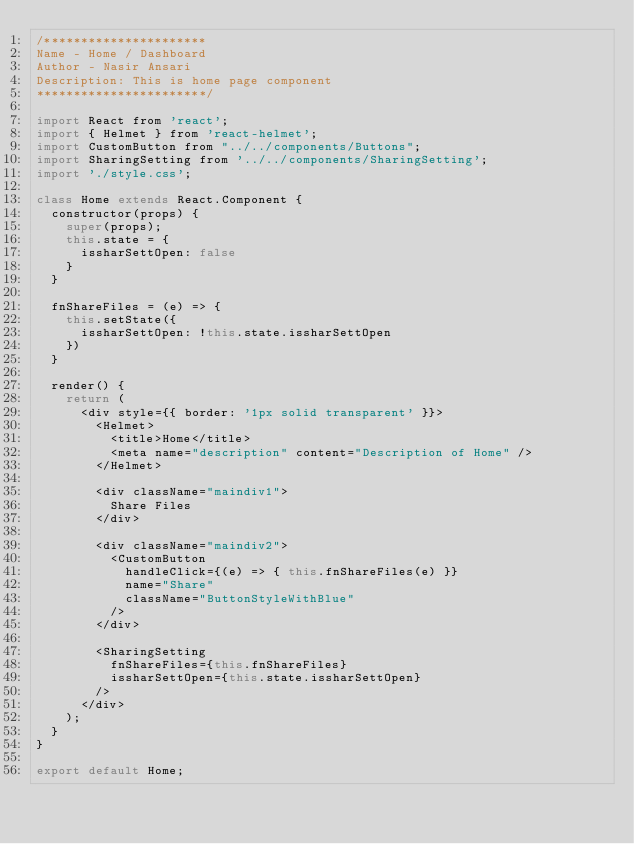<code> <loc_0><loc_0><loc_500><loc_500><_JavaScript_>/**********************
Name - Home / Dashboard
Author - Nasir Ansari
Description: This is home page component
***********************/

import React from 'react';
import { Helmet } from 'react-helmet';
import CustomButton from "../../components/Buttons";
import SharingSetting from '../../components/SharingSetting';
import './style.css';

class Home extends React.Component {
  constructor(props) {
    super(props);
    this.state = {
      issharSettOpen: false
    }
  }

  fnShareFiles = (e) => {
    this.setState({
      issharSettOpen: !this.state.issharSettOpen
    })
  }

  render() {
    return (
      <div style={{ border: '1px solid transparent' }}>
        <Helmet>
          <title>Home</title>
          <meta name="description" content="Description of Home" />
        </Helmet>

        <div className="maindiv1">
          Share Files
        </div>

        <div className="maindiv2">
          <CustomButton
            handleClick={(e) => { this.fnShareFiles(e) }}
            name="Share"
            className="ButtonStyleWithBlue"
          />
        </div>

        <SharingSetting
          fnShareFiles={this.fnShareFiles}
          issharSettOpen={this.state.issharSettOpen}
        />
      </div>
    );
  }
}

export default Home;

</code> 